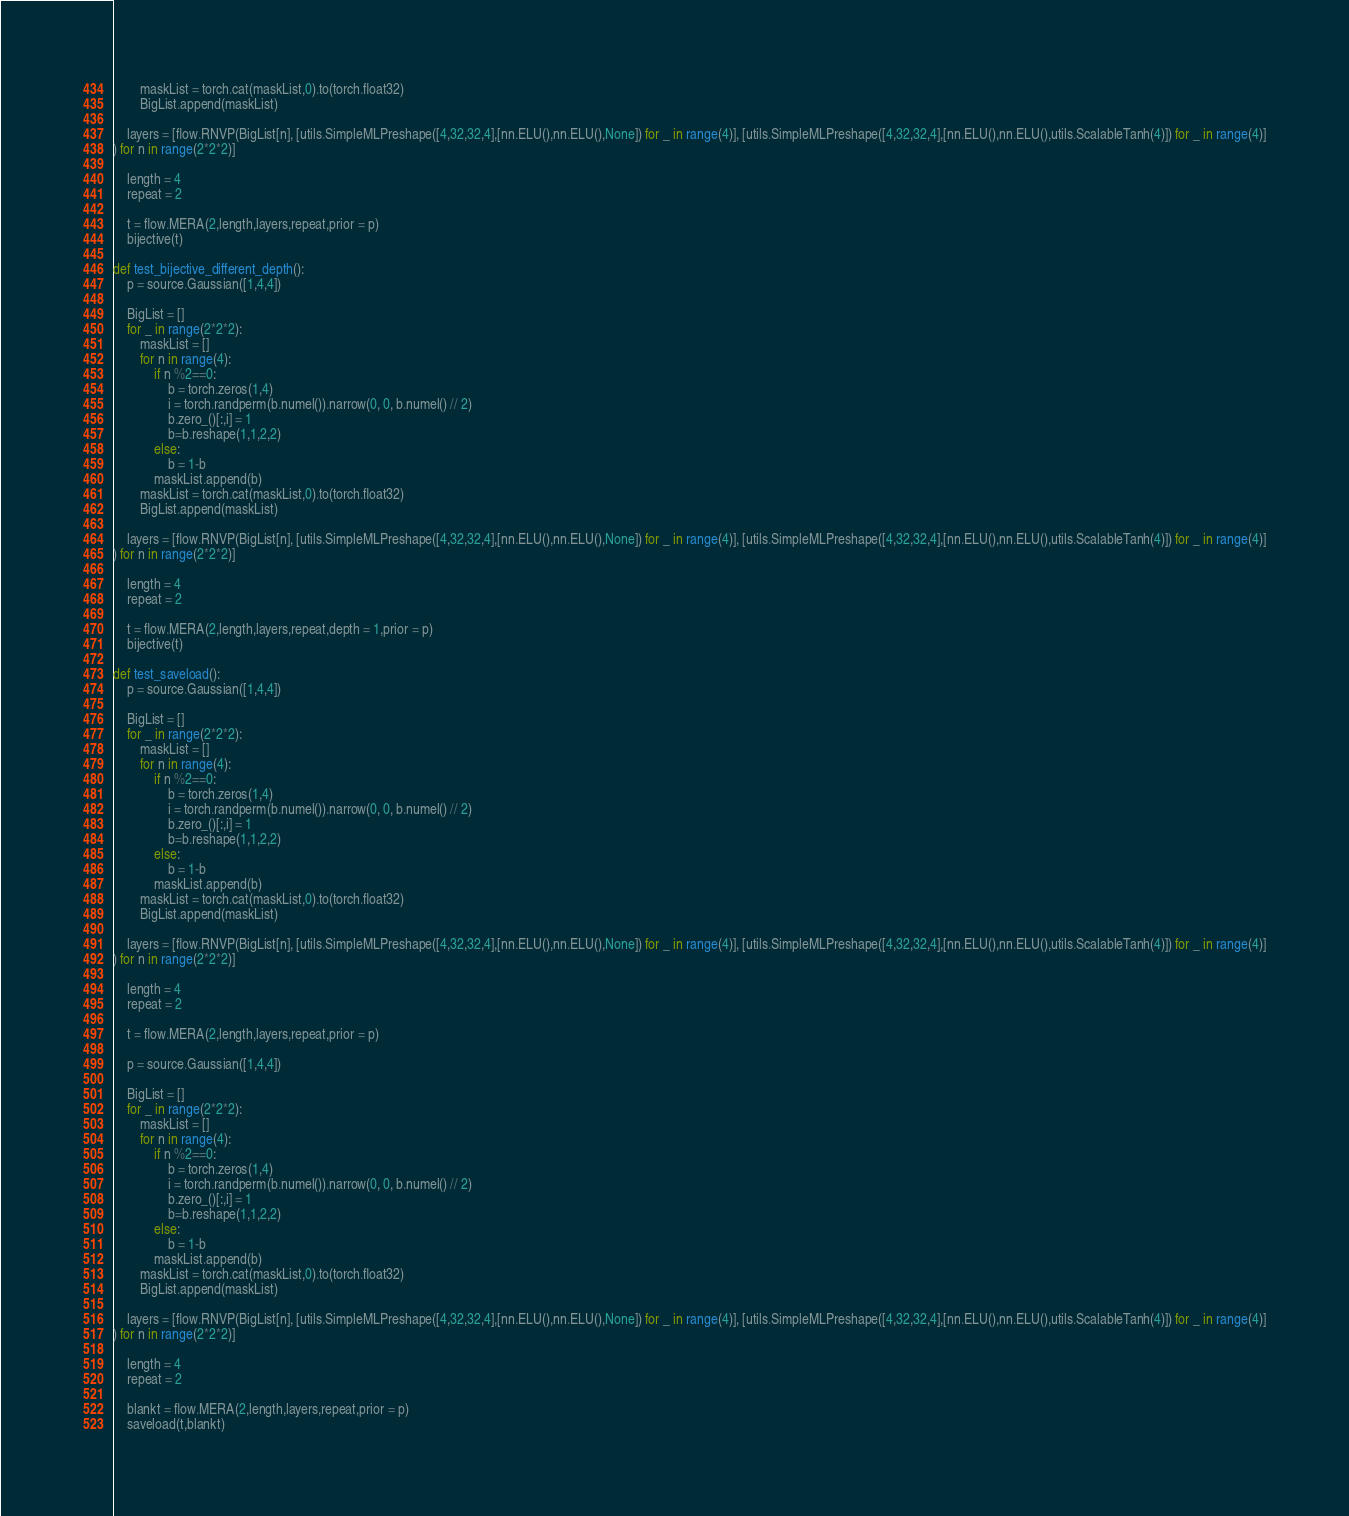<code> <loc_0><loc_0><loc_500><loc_500><_Python_>        maskList = torch.cat(maskList,0).to(torch.float32)
        BigList.append(maskList)

    layers = [flow.RNVP(BigList[n], [utils.SimpleMLPreshape([4,32,32,4],[nn.ELU(),nn.ELU(),None]) for _ in range(4)], [utils.SimpleMLPreshape([4,32,32,4],[nn.ELU(),nn.ELU(),utils.ScalableTanh(4)]) for _ in range(4)]
) for n in range(2*2*2)]

    length = 4
    repeat = 2

    t = flow.MERA(2,length,layers,repeat,prior = p)
    bijective(t)

def test_bijective_different_depth():
    p = source.Gaussian([1,4,4])

    BigList = []
    for _ in range(2*2*2):
        maskList = []
        for n in range(4):
            if n %2==0:
                b = torch.zeros(1,4)
                i = torch.randperm(b.numel()).narrow(0, 0, b.numel() // 2)
                b.zero_()[:,i] = 1
                b=b.reshape(1,1,2,2)
            else:
                b = 1-b
            maskList.append(b)
        maskList = torch.cat(maskList,0).to(torch.float32)
        BigList.append(maskList)

    layers = [flow.RNVP(BigList[n], [utils.SimpleMLPreshape([4,32,32,4],[nn.ELU(),nn.ELU(),None]) for _ in range(4)], [utils.SimpleMLPreshape([4,32,32,4],[nn.ELU(),nn.ELU(),utils.ScalableTanh(4)]) for _ in range(4)]
) for n in range(2*2*2)]

    length = 4
    repeat = 2

    t = flow.MERA(2,length,layers,repeat,depth = 1,prior = p)
    bijective(t)

def test_saveload():
    p = source.Gaussian([1,4,4])

    BigList = []
    for _ in range(2*2*2):
        maskList = []
        for n in range(4):
            if n %2==0:
                b = torch.zeros(1,4)
                i = torch.randperm(b.numel()).narrow(0, 0, b.numel() // 2)
                b.zero_()[:,i] = 1
                b=b.reshape(1,1,2,2)
            else:
                b = 1-b
            maskList.append(b)
        maskList = torch.cat(maskList,0).to(torch.float32)
        BigList.append(maskList)

    layers = [flow.RNVP(BigList[n], [utils.SimpleMLPreshape([4,32,32,4],[nn.ELU(),nn.ELU(),None]) for _ in range(4)], [utils.SimpleMLPreshape([4,32,32,4],[nn.ELU(),nn.ELU(),utils.ScalableTanh(4)]) for _ in range(4)]
) for n in range(2*2*2)]

    length = 4
    repeat = 2

    t = flow.MERA(2,length,layers,repeat,prior = p)

    p = source.Gaussian([1,4,4])

    BigList = []
    for _ in range(2*2*2):
        maskList = []
        for n in range(4):
            if n %2==0:
                b = torch.zeros(1,4)
                i = torch.randperm(b.numel()).narrow(0, 0, b.numel() // 2)
                b.zero_()[:,i] = 1
                b=b.reshape(1,1,2,2)
            else:
                b = 1-b
            maskList.append(b)
        maskList = torch.cat(maskList,0).to(torch.float32)
        BigList.append(maskList)

    layers = [flow.RNVP(BigList[n], [utils.SimpleMLPreshape([4,32,32,4],[nn.ELU(),nn.ELU(),None]) for _ in range(4)], [utils.SimpleMLPreshape([4,32,32,4],[nn.ELU(),nn.ELU(),utils.ScalableTanh(4)]) for _ in range(4)]
) for n in range(2*2*2)]

    length = 4
    repeat = 2

    blankt = flow.MERA(2,length,layers,repeat,prior = p)
    saveload(t,blankt)</code> 